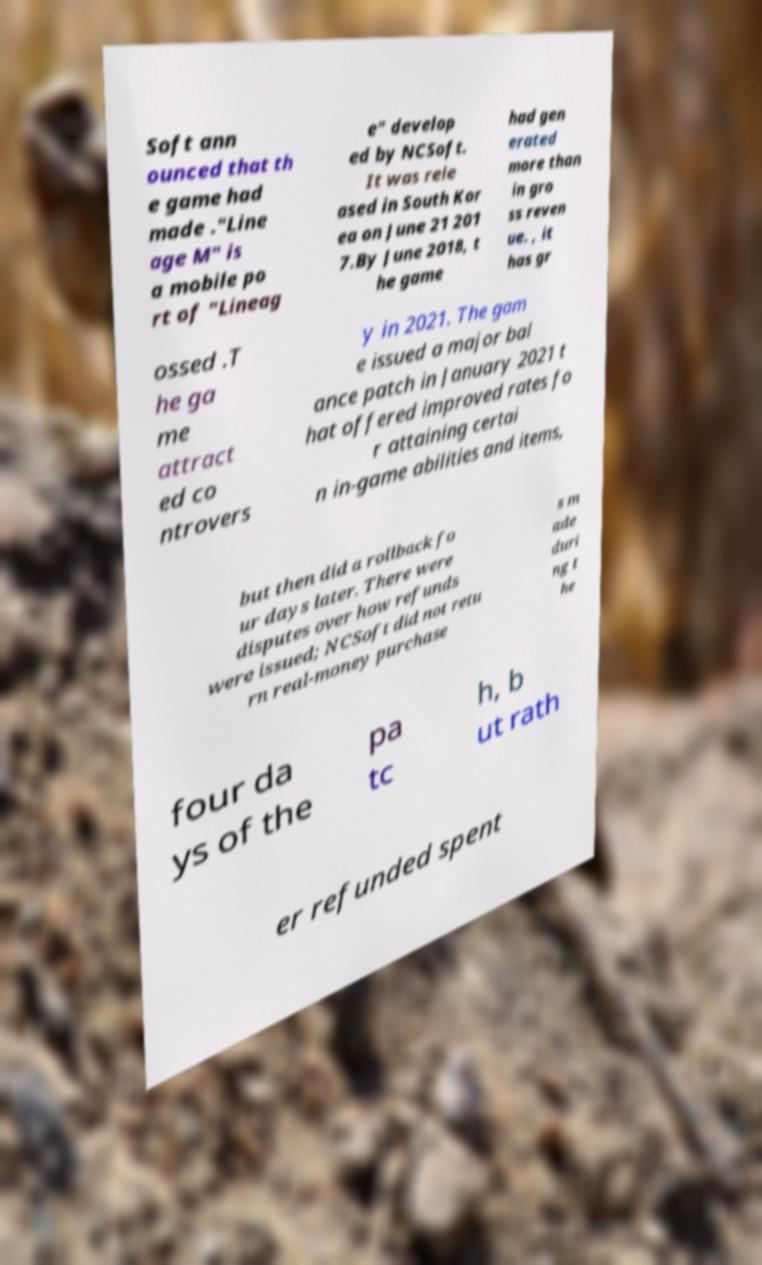There's text embedded in this image that I need extracted. Can you transcribe it verbatim? Soft ann ounced that th e game had made ."Line age M" is a mobile po rt of "Lineag e" develop ed by NCSoft. It was rele ased in South Kor ea on June 21 201 7.By June 2018, t he game had gen erated more than in gro ss reven ue. , it has gr ossed .T he ga me attract ed co ntrovers y in 2021. The gam e issued a major bal ance patch in January 2021 t hat offered improved rates fo r attaining certai n in-game abilities and items, but then did a rollback fo ur days later. There were disputes over how refunds were issued; NCSoft did not retu rn real-money purchase s m ade duri ng t he four da ys of the pa tc h, b ut rath er refunded spent 